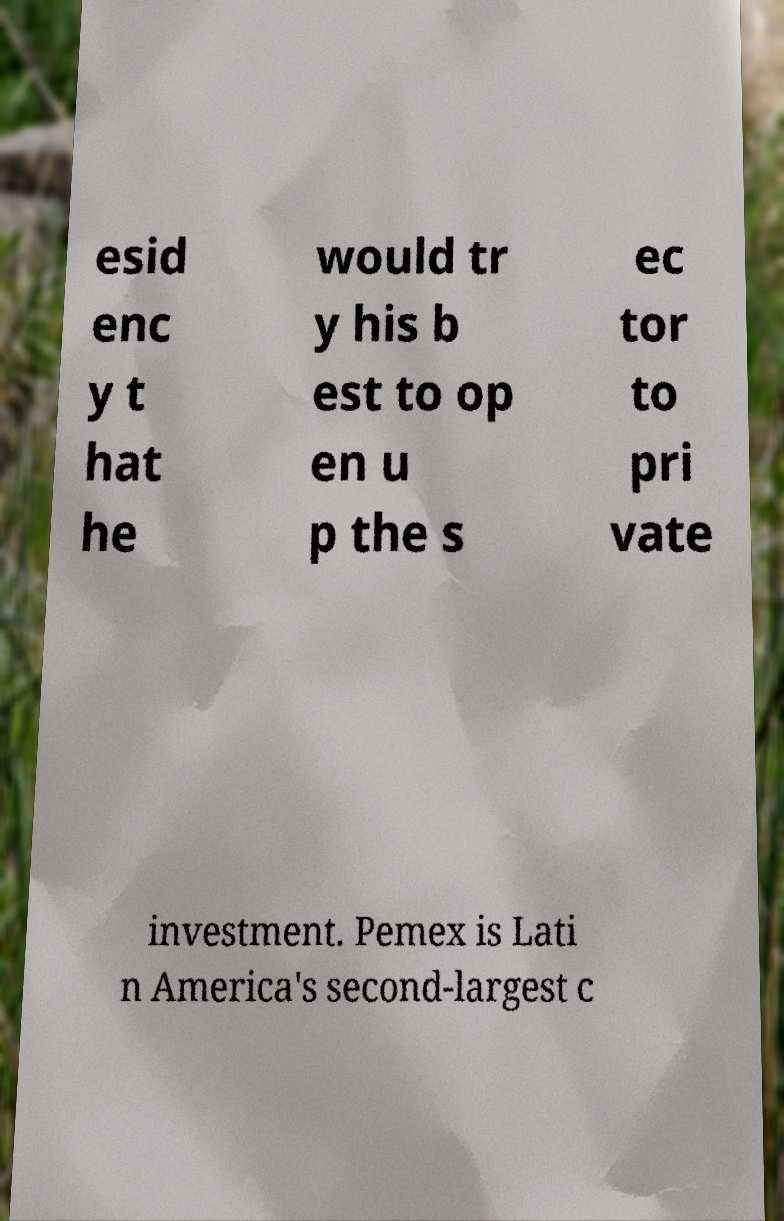Can you read and provide the text displayed in the image?This photo seems to have some interesting text. Can you extract and type it out for me? esid enc y t hat he would tr y his b est to op en u p the s ec tor to pri vate investment. Pemex is Lati n America's second-largest c 